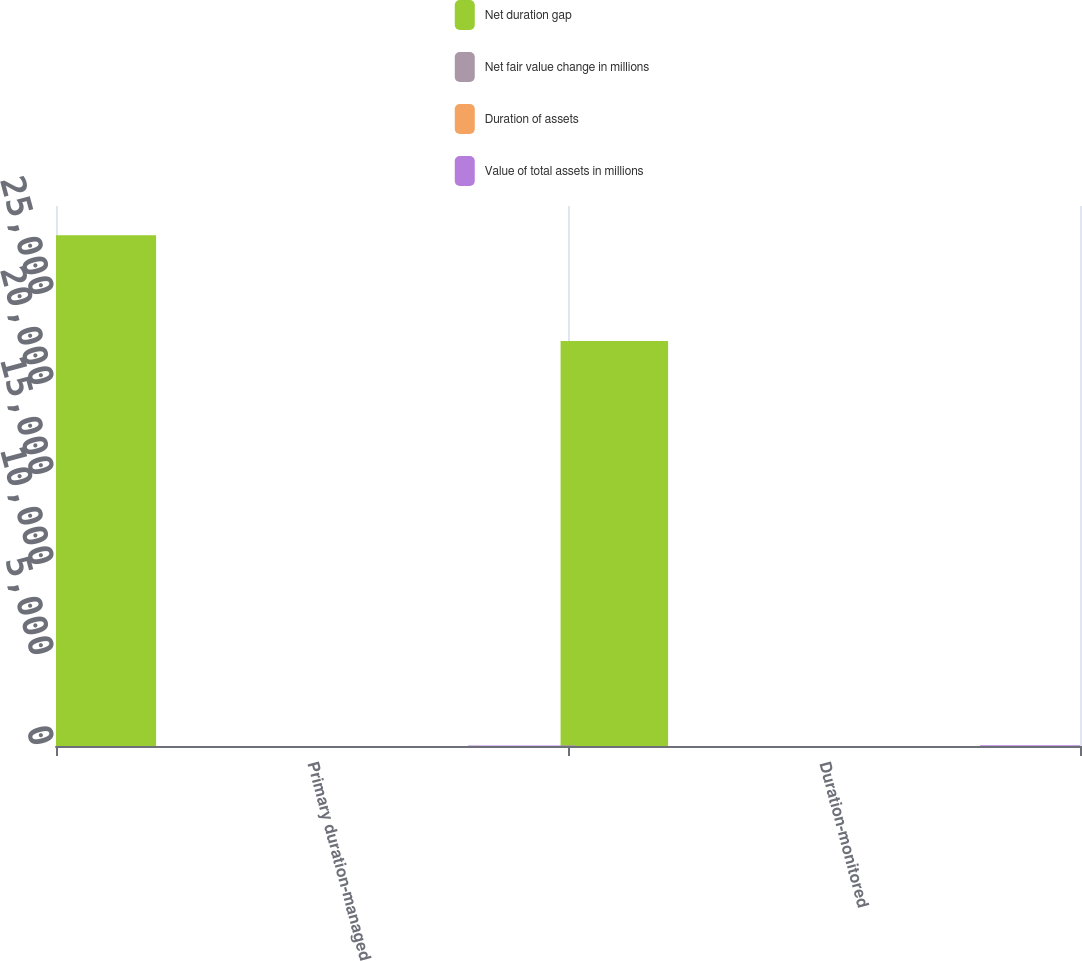Convert chart. <chart><loc_0><loc_0><loc_500><loc_500><stacked_bar_chart><ecel><fcel>Primary duration-managed<fcel>Duration-monitored<nl><fcel>Net duration gap<fcel>28377.1<fcel>22497.1<nl><fcel>Net fair value change in millions<fcel>3.4<fcel>4.13<nl><fcel>Duration of assets<fcel>0.12<fcel>0.16<nl><fcel>Value of total assets in millions<fcel>34.1<fcel>37<nl></chart> 